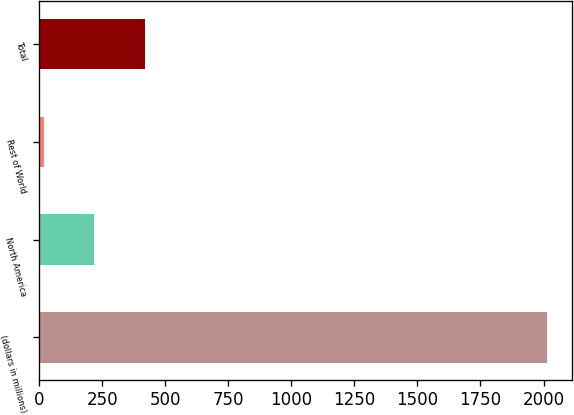Convert chart to OTSL. <chart><loc_0><loc_0><loc_500><loc_500><bar_chart><fcel>(dollars in millions)<fcel>North America<fcel>Rest of World<fcel>Total<nl><fcel>2014<fcel>219.4<fcel>20<fcel>418.8<nl></chart> 